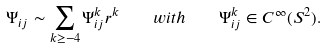Convert formula to latex. <formula><loc_0><loc_0><loc_500><loc_500>\Psi _ { i j } \sim \sum _ { k \geq - 4 } \Psi ^ { k } _ { i j } r ^ { k } \quad w i t h \quad \Psi ^ { k } _ { i j } \in C ^ { \infty } ( S ^ { 2 } ) .</formula> 